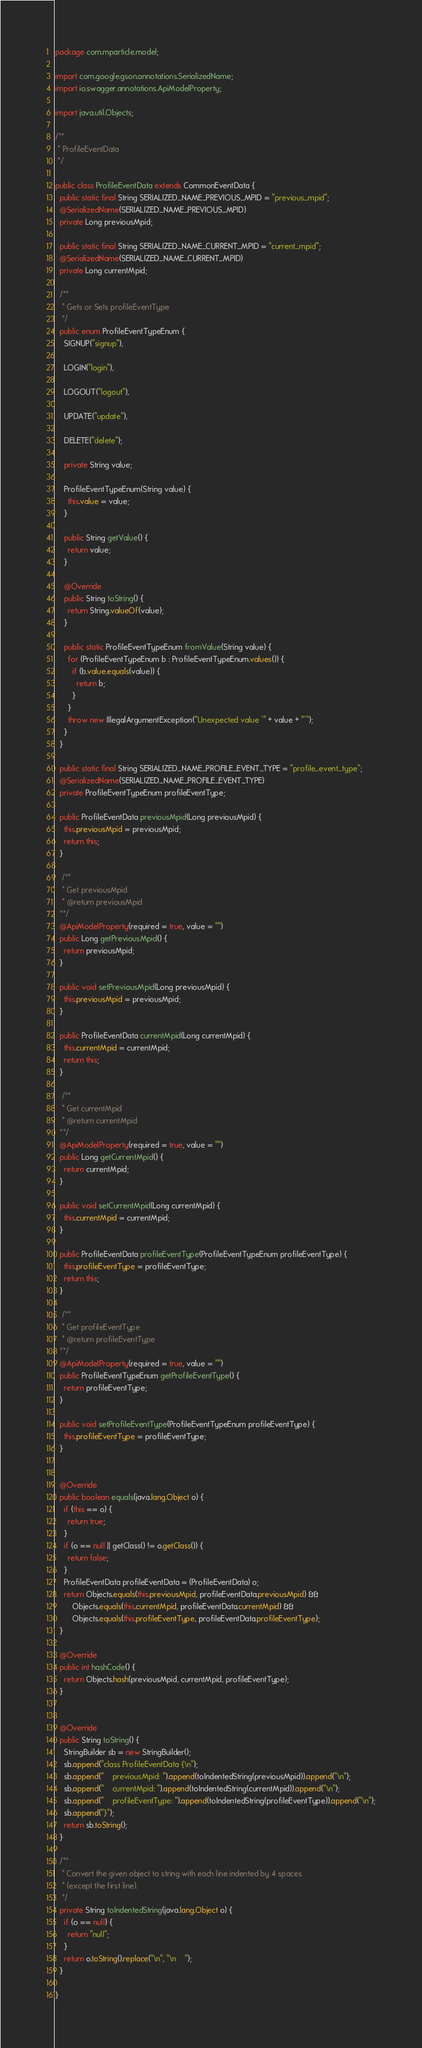Convert code to text. <code><loc_0><loc_0><loc_500><loc_500><_Java_>package com.mparticle.model;

import com.google.gson.annotations.SerializedName;
import io.swagger.annotations.ApiModelProperty;

import java.util.Objects;

/**
 * ProfileEventData
 */

public class ProfileEventData extends CommonEventData {
  public static final String SERIALIZED_NAME_PREVIOUS_MPID = "previous_mpid";
  @SerializedName(SERIALIZED_NAME_PREVIOUS_MPID)
  private Long previousMpid;

  public static final String SERIALIZED_NAME_CURRENT_MPID = "current_mpid";
  @SerializedName(SERIALIZED_NAME_CURRENT_MPID)
  private Long currentMpid;

  /**
   * Gets or Sets profileEventType
   */
  public enum ProfileEventTypeEnum {
    SIGNUP("signup"),
    
    LOGIN("login"),
    
    LOGOUT("logout"),
    
    UPDATE("update"),
    
    DELETE("delete");

    private String value;

    ProfileEventTypeEnum(String value) {
      this.value = value;
    }

    public String getValue() {
      return value;
    }

    @Override
    public String toString() {
      return String.valueOf(value);
    }

    public static ProfileEventTypeEnum fromValue(String value) {
      for (ProfileEventTypeEnum b : ProfileEventTypeEnum.values()) {
        if (b.value.equals(value)) {
          return b;
        }
      }
      throw new IllegalArgumentException("Unexpected value '" + value + "'");
    }
  }

  public static final String SERIALIZED_NAME_PROFILE_EVENT_TYPE = "profile_event_type";
  @SerializedName(SERIALIZED_NAME_PROFILE_EVENT_TYPE)
  private ProfileEventTypeEnum profileEventType;

  public ProfileEventData previousMpid(Long previousMpid) {
    this.previousMpid = previousMpid;
    return this;
  }

   /**
   * Get previousMpid
   * @return previousMpid
  **/
  @ApiModelProperty(required = true, value = "")
  public Long getPreviousMpid() {
    return previousMpid;
  }

  public void setPreviousMpid(Long previousMpid) {
    this.previousMpid = previousMpid;
  }

  public ProfileEventData currentMpid(Long currentMpid) {
    this.currentMpid = currentMpid;
    return this;
  }

   /**
   * Get currentMpid
   * @return currentMpid
  **/
  @ApiModelProperty(required = true, value = "")
  public Long getCurrentMpid() {
    return currentMpid;
  }

  public void setCurrentMpid(Long currentMpid) {
    this.currentMpid = currentMpid;
  }

  public ProfileEventData profileEventType(ProfileEventTypeEnum profileEventType) {
    this.profileEventType = profileEventType;
    return this;
  }

   /**
   * Get profileEventType
   * @return profileEventType
  **/
  @ApiModelProperty(required = true, value = "")
  public ProfileEventTypeEnum getProfileEventType() {
    return profileEventType;
  }

  public void setProfileEventType(ProfileEventTypeEnum profileEventType) {
    this.profileEventType = profileEventType;
  }


  @Override
  public boolean equals(java.lang.Object o) {
    if (this == o) {
      return true;
    }
    if (o == null || getClass() != o.getClass()) {
      return false;
    }
    ProfileEventData profileEventData = (ProfileEventData) o;
    return Objects.equals(this.previousMpid, profileEventData.previousMpid) &&
        Objects.equals(this.currentMpid, profileEventData.currentMpid) &&
        Objects.equals(this.profileEventType, profileEventData.profileEventType);
  }

  @Override
  public int hashCode() {
    return Objects.hash(previousMpid, currentMpid, profileEventType);
  }


  @Override
  public String toString() {
    StringBuilder sb = new StringBuilder();
    sb.append("class ProfileEventData {\n");
    sb.append("    previousMpid: ").append(toIndentedString(previousMpid)).append("\n");
    sb.append("    currentMpid: ").append(toIndentedString(currentMpid)).append("\n");
    sb.append("    profileEventType: ").append(toIndentedString(profileEventType)).append("\n");
    sb.append("}");
    return sb.toString();
  }

  /**
   * Convert the given object to string with each line indented by 4 spaces
   * (except the first line).
   */
  private String toIndentedString(java.lang.Object o) {
    if (o == null) {
      return "null";
    }
    return o.toString().replace("\n", "\n    ");
  }

}

</code> 